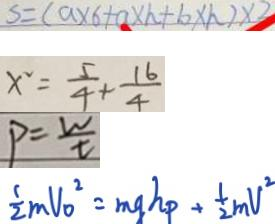<formula> <loc_0><loc_0><loc_500><loc_500>S = ( a \times 6 + a \times h + b \times h ) \times 3 
 x ^ { 2 } = \frac { 5 } { 4 } + \frac { 1 6 } { 4 } 
 P = \frac { W } { t } 
 \frac { 1 } { 2 } m V _ { 0 } ^ { 2 } = m g h _ { p } + \frac { 1 } { 2 } m v ^ { 2 }</formula> 